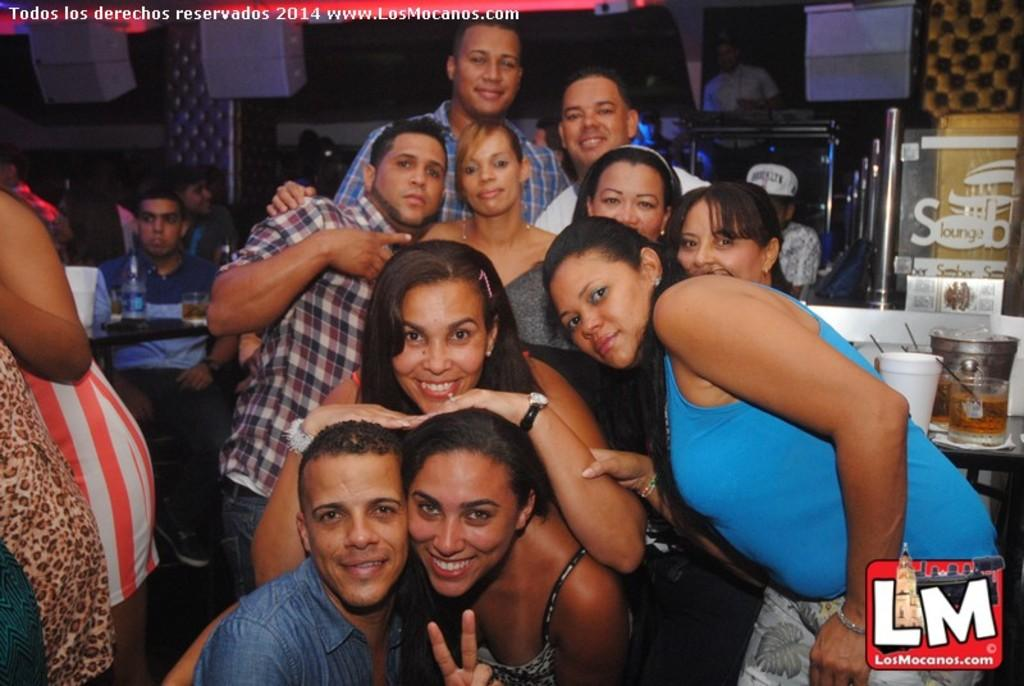How many people are in the image? There is a group of people in the image. Can you describe the expressions of some of the people? Some of the people are smiling. What can be seen in the background of the image? There is a table in the background of the image. What objects are on the table? There is a bottle and a glass on the table. Are there any other people visible in the image? Yes, there are also people in the background of the image. What type of downtown area is depicted in the image? There is no downtown area depicted in the image; it features a group of people and a table with objects. How does the person in the image control the flow of traffic? There is no person controlling traffic in the image; it focuses on a group of people and a table with objects. 